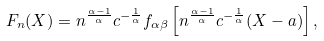<formula> <loc_0><loc_0><loc_500><loc_500>F _ { n } ( X ) = n ^ { \frac { \alpha - 1 } { \alpha } } c ^ { - \frac { 1 } { \alpha } } f _ { \alpha \beta } \left [ n ^ { \frac { \alpha - 1 } { \alpha } } c ^ { - \frac { 1 } { \alpha } } ( X - a ) \right ] ,</formula> 